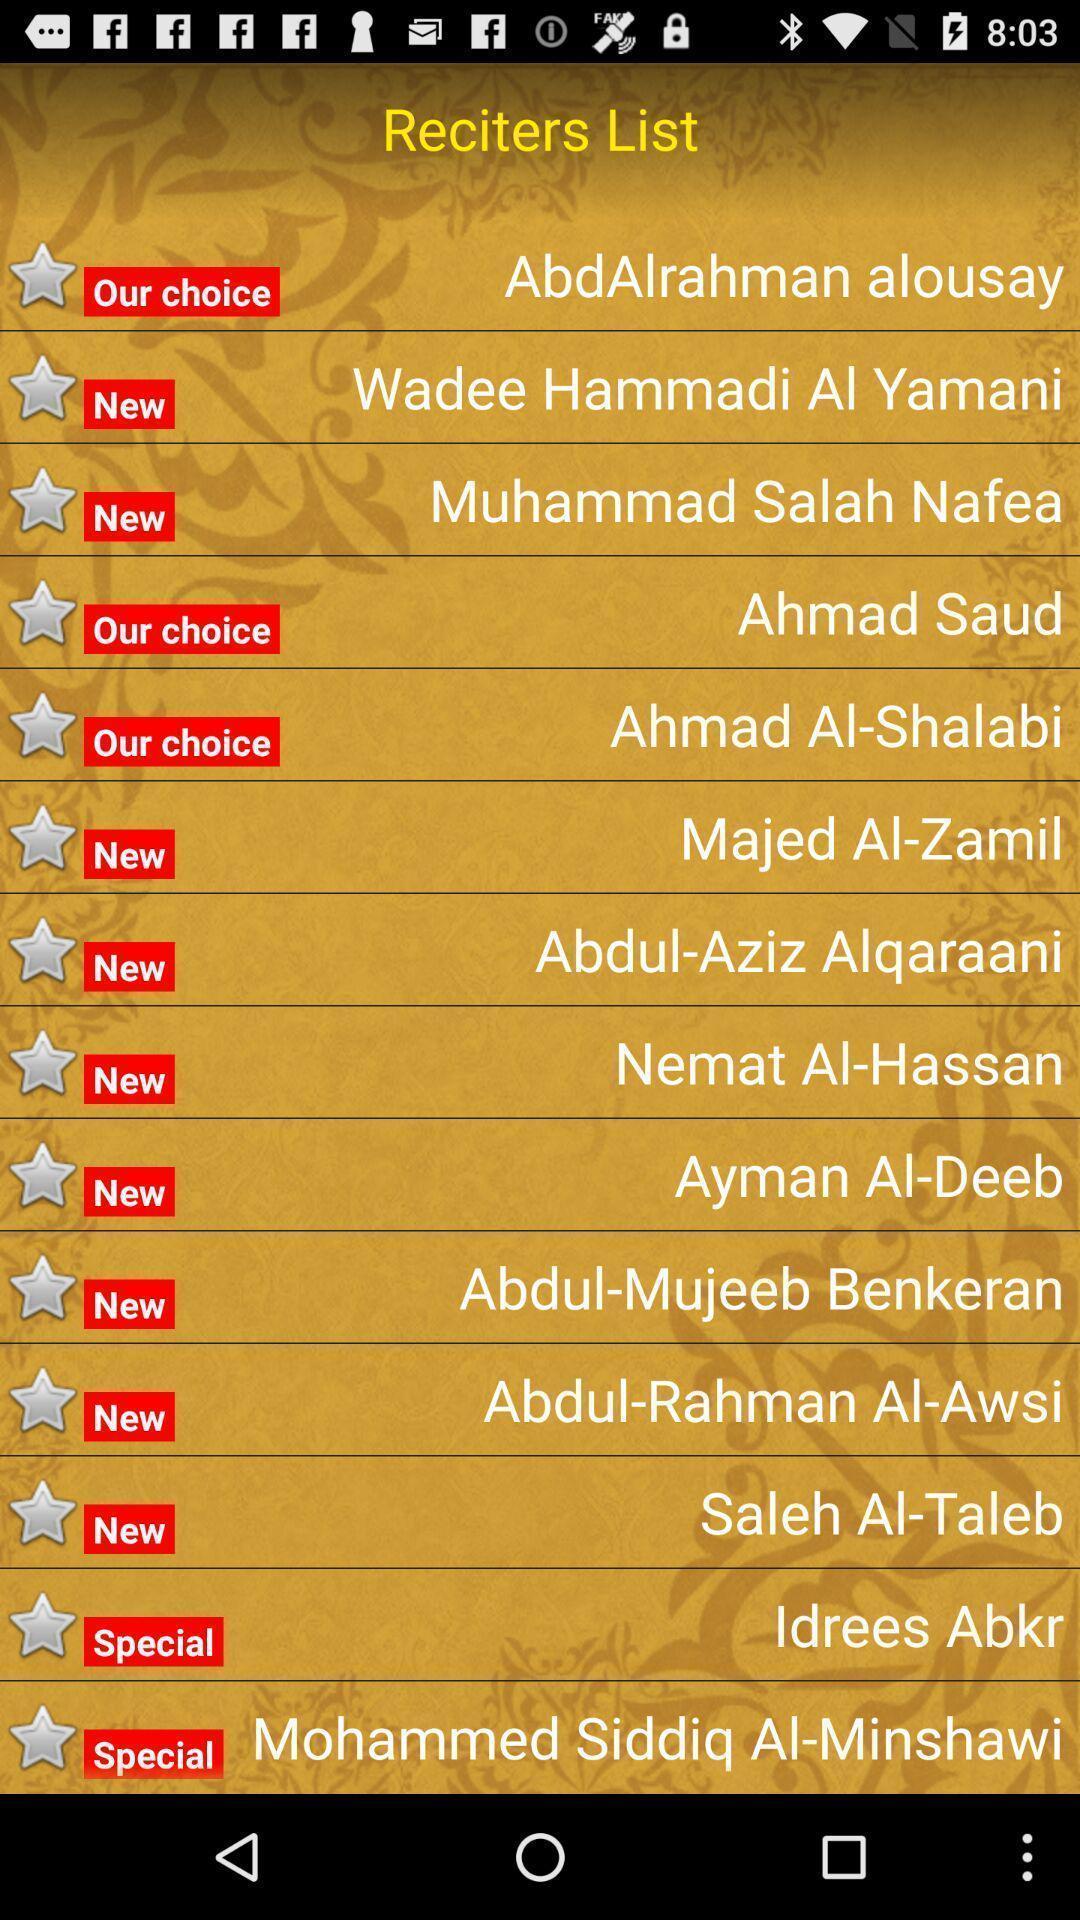What details can you identify in this image? Screen showing list of reciters. 